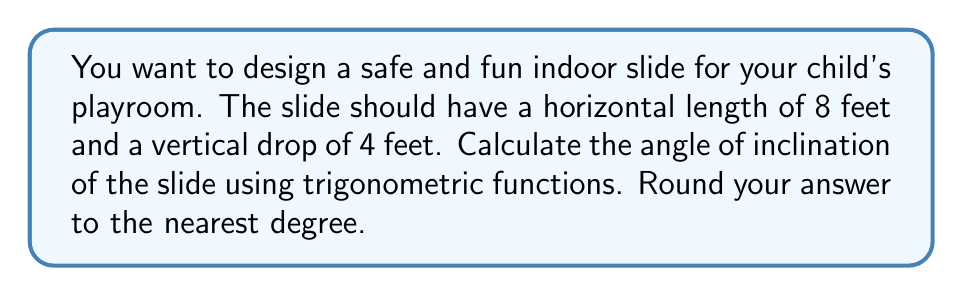Show me your answer to this math problem. Let's approach this step-by-step:

1) First, let's visualize the slide as a right triangle:

[asy]
import geometry;

size(200);
pair A = (0,0), B = (8,0), C = (0,4);
draw(A--B--C--A);
label("8 ft", (4,0), S);
label("4 ft", (0,2), W);
label("θ", (0.5,0.2), NW);
[/asy]

2) In this right triangle:
   - The horizontal length (8 feet) represents the adjacent side to the angle of inclination.
   - The vertical drop (4 feet) represents the opposite side.
   - The angle of inclination is what we're trying to find.

3) We can use the tangent function to find this angle. Recall that:

   $$\tan(\theta) = \frac{\text{opposite}}{\text{adjacent}}$$

4) Plugging in our values:

   $$\tan(\theta) = \frac{4}{8} = \frac{1}{2} = 0.5$$

5) To find the angle, we need to use the inverse tangent function (arctan or $\tan^{-1}$):

   $$\theta = \tan^{-1}(0.5)$$

6) Using a calculator or computer:

   $$\theta \approx 26.57°$$

7) Rounding to the nearest degree:

   $$\theta \approx 27°$$
Answer: $27°$ 